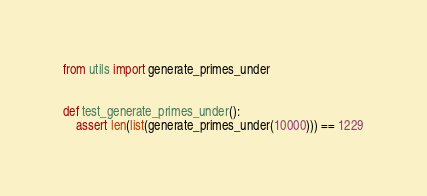<code> <loc_0><loc_0><loc_500><loc_500><_Python_>from utils import generate_primes_under


def test_generate_primes_under():
	assert len(list(generate_primes_under(10000))) == 1229
</code> 